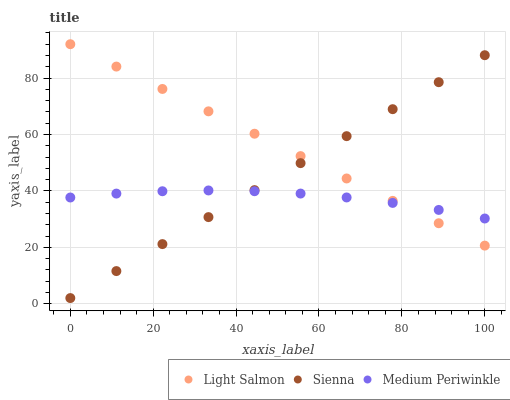Does Medium Periwinkle have the minimum area under the curve?
Answer yes or no. Yes. Does Light Salmon have the maximum area under the curve?
Answer yes or no. Yes. Does Light Salmon have the minimum area under the curve?
Answer yes or no. No. Does Medium Periwinkle have the maximum area under the curve?
Answer yes or no. No. Is Light Salmon the smoothest?
Answer yes or no. Yes. Is Medium Periwinkle the roughest?
Answer yes or no. Yes. Is Medium Periwinkle the smoothest?
Answer yes or no. No. Is Light Salmon the roughest?
Answer yes or no. No. Does Sienna have the lowest value?
Answer yes or no. Yes. Does Light Salmon have the lowest value?
Answer yes or no. No. Does Light Salmon have the highest value?
Answer yes or no. Yes. Does Medium Periwinkle have the highest value?
Answer yes or no. No. Does Sienna intersect Medium Periwinkle?
Answer yes or no. Yes. Is Sienna less than Medium Periwinkle?
Answer yes or no. No. Is Sienna greater than Medium Periwinkle?
Answer yes or no. No. 